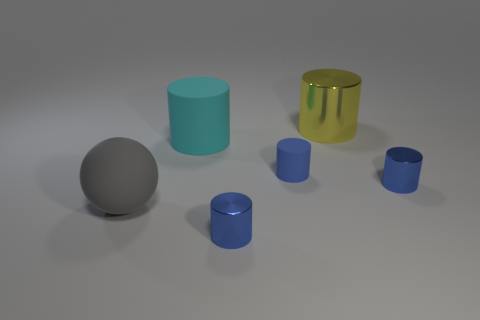Subtract all red blocks. How many blue cylinders are left? 3 Subtract all blue cylinders. How many cylinders are left? 2 Add 3 tiny purple matte objects. How many objects exist? 9 Subtract all balls. How many objects are left? 5 Subtract all yellow cylinders. How many cylinders are left? 4 Subtract 0 purple cylinders. How many objects are left? 6 Subtract all red cylinders. Subtract all gray spheres. How many cylinders are left? 5 Subtract all yellow cylinders. Subtract all yellow cylinders. How many objects are left? 4 Add 1 big gray balls. How many big gray balls are left? 2 Add 5 small shiny cubes. How many small shiny cubes exist? 5 